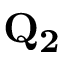<formula> <loc_0><loc_0><loc_500><loc_500>Q _ { 2 }</formula> 